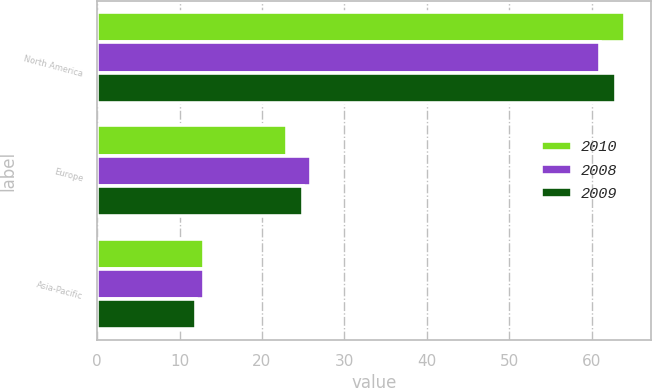Convert chart. <chart><loc_0><loc_0><loc_500><loc_500><stacked_bar_chart><ecel><fcel>North America<fcel>Europe<fcel>Asia-Pacific<nl><fcel>2010<fcel>64<fcel>23<fcel>13<nl><fcel>2008<fcel>61<fcel>26<fcel>13<nl><fcel>2009<fcel>63<fcel>25<fcel>12<nl></chart> 